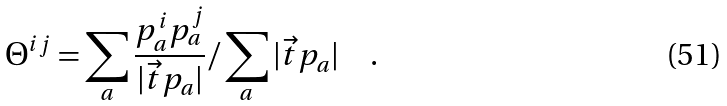<formula> <loc_0><loc_0><loc_500><loc_500>\Theta ^ { i j } = \sum _ { a } \frac { p _ { a } ^ { i } p _ { a } ^ { j } } { | \vec { t } { p } _ { a } | } / \sum _ { a } | \vec { t } { p } _ { a } | \quad .</formula> 